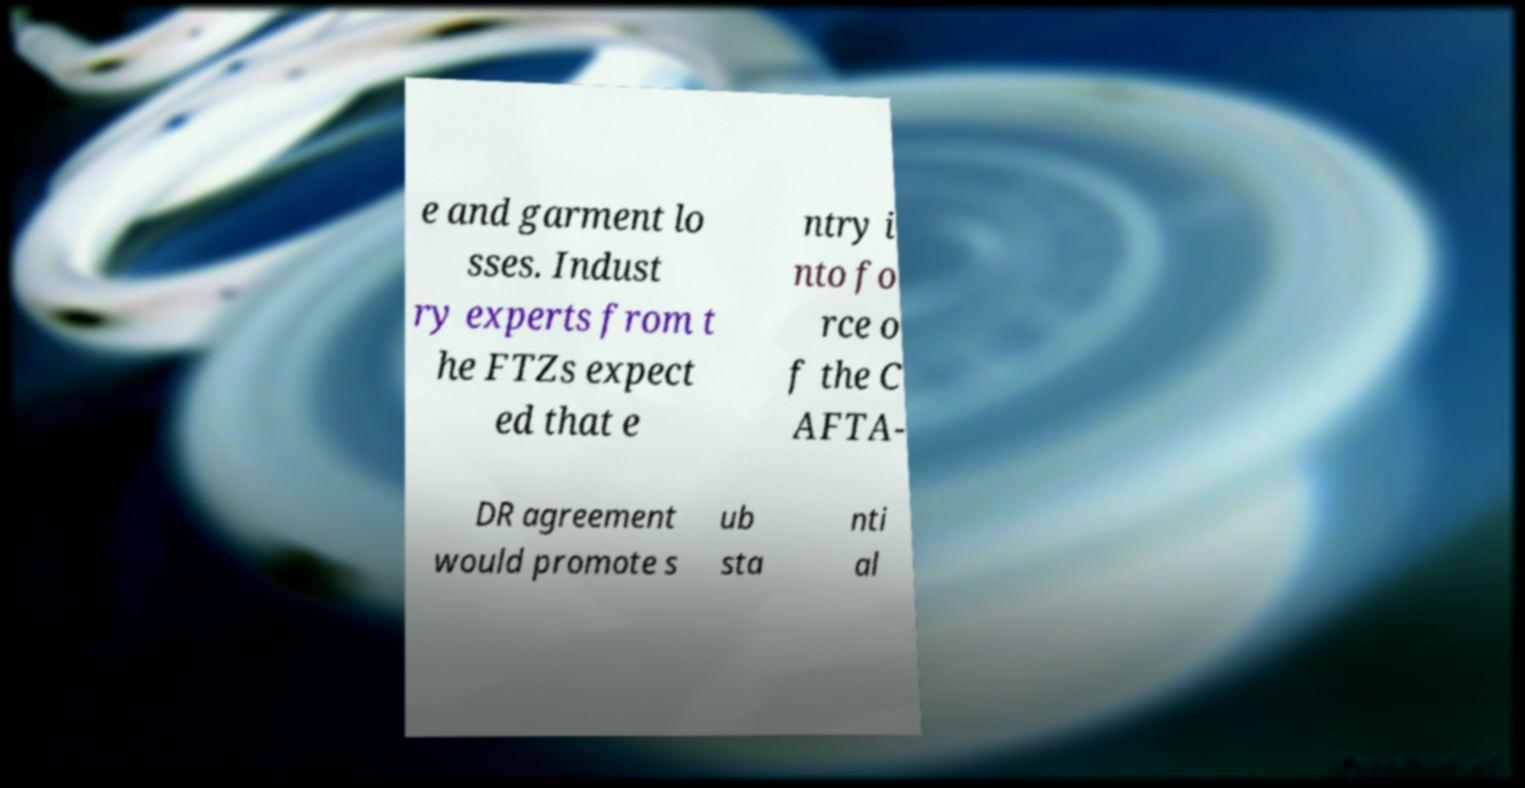Can you accurately transcribe the text from the provided image for me? e and garment lo sses. Indust ry experts from t he FTZs expect ed that e ntry i nto fo rce o f the C AFTA- DR agreement would promote s ub sta nti al 